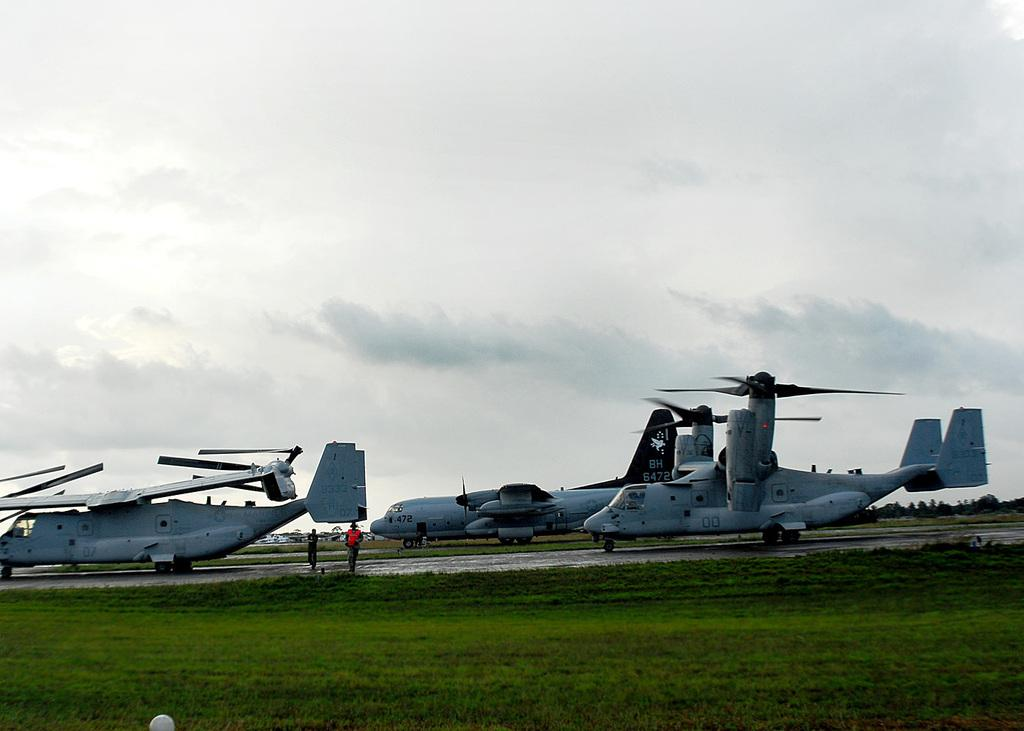What type of vehicles are on the land in the image? There are aircrafts on the land in the image. Can you describe the people in the image? There are two people between the aircrafts. What is visible in the foreground of the image? There is a lot of grass in the foreground of the image. What is the name of the daughter of the person in the image? There is no mention of a daughter or any person's name in the image, so it cannot be determined. 